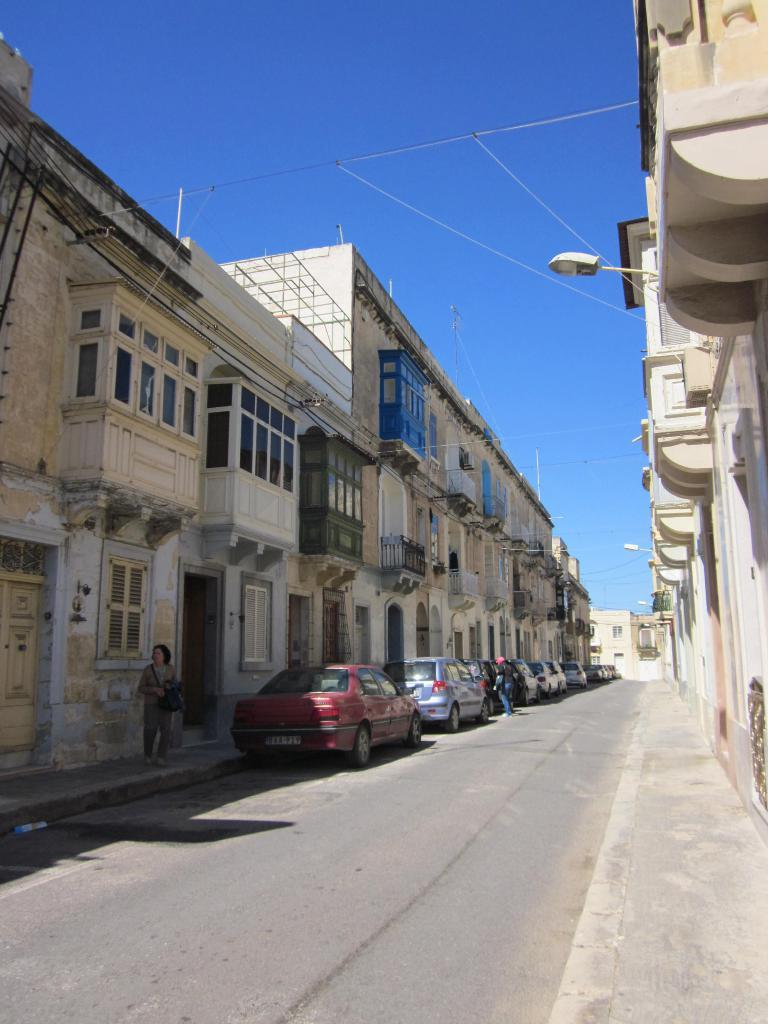What type of structures can be seen in the image? There are buildings in the image. What mode of transportation is present on the road in the image? There are cars on the road in the image. Can you identify any living beings in the image? Yes, there are people in the image. What is visible in the background of the image? The sky is visible in the background of the image. What type of substance is being studied by the people in the image? There is no indication of any substance being studied in the image; it primarily features buildings, cars, and people. What scientific experiment is being conducted in the image? There is no scientific experiment depicted in the image. 